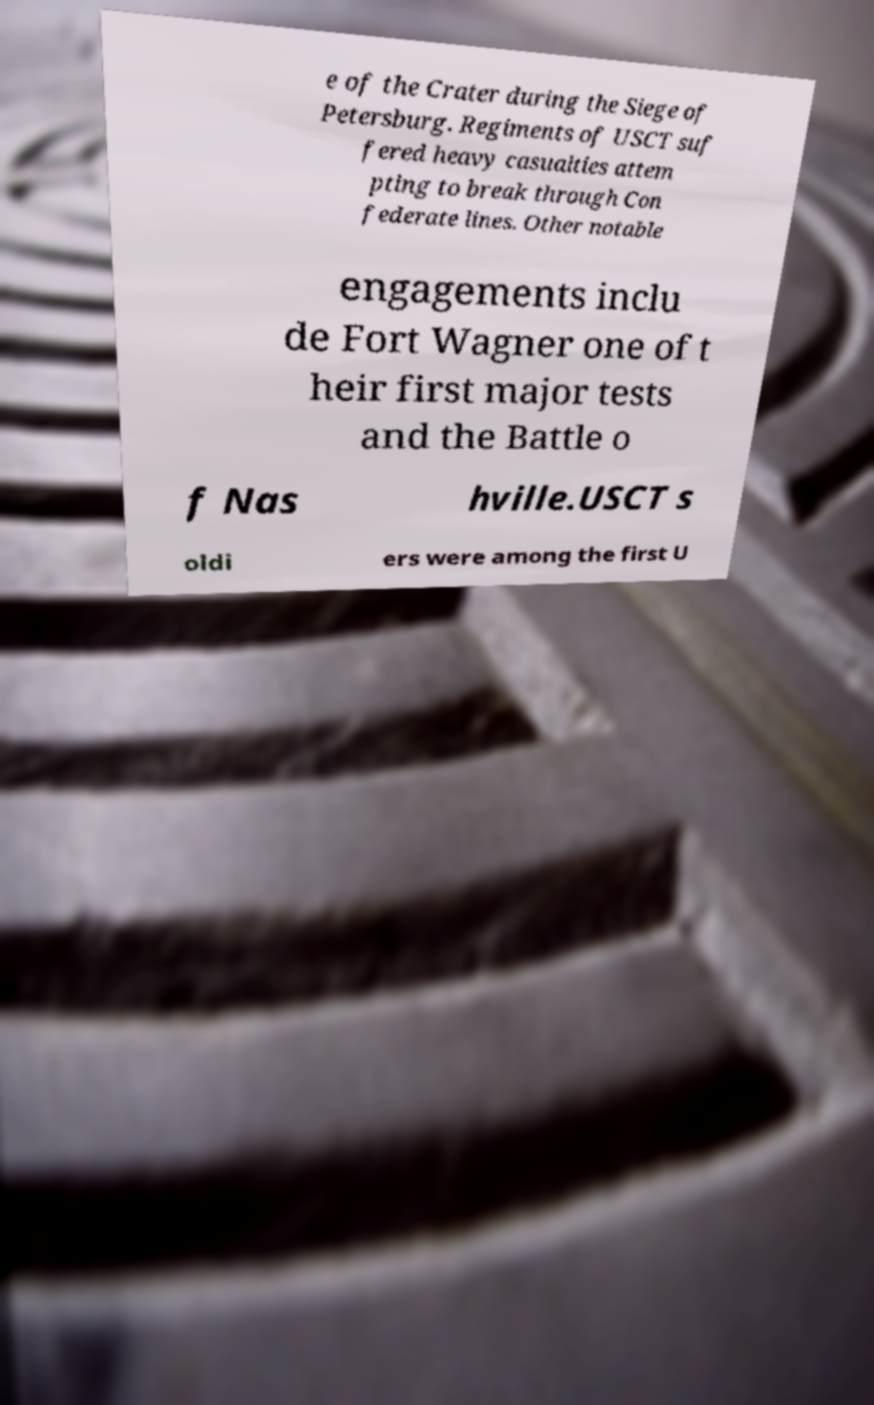Could you extract and type out the text from this image? e of the Crater during the Siege of Petersburg. Regiments of USCT suf fered heavy casualties attem pting to break through Con federate lines. Other notable engagements inclu de Fort Wagner one of t heir first major tests and the Battle o f Nas hville.USCT s oldi ers were among the first U 